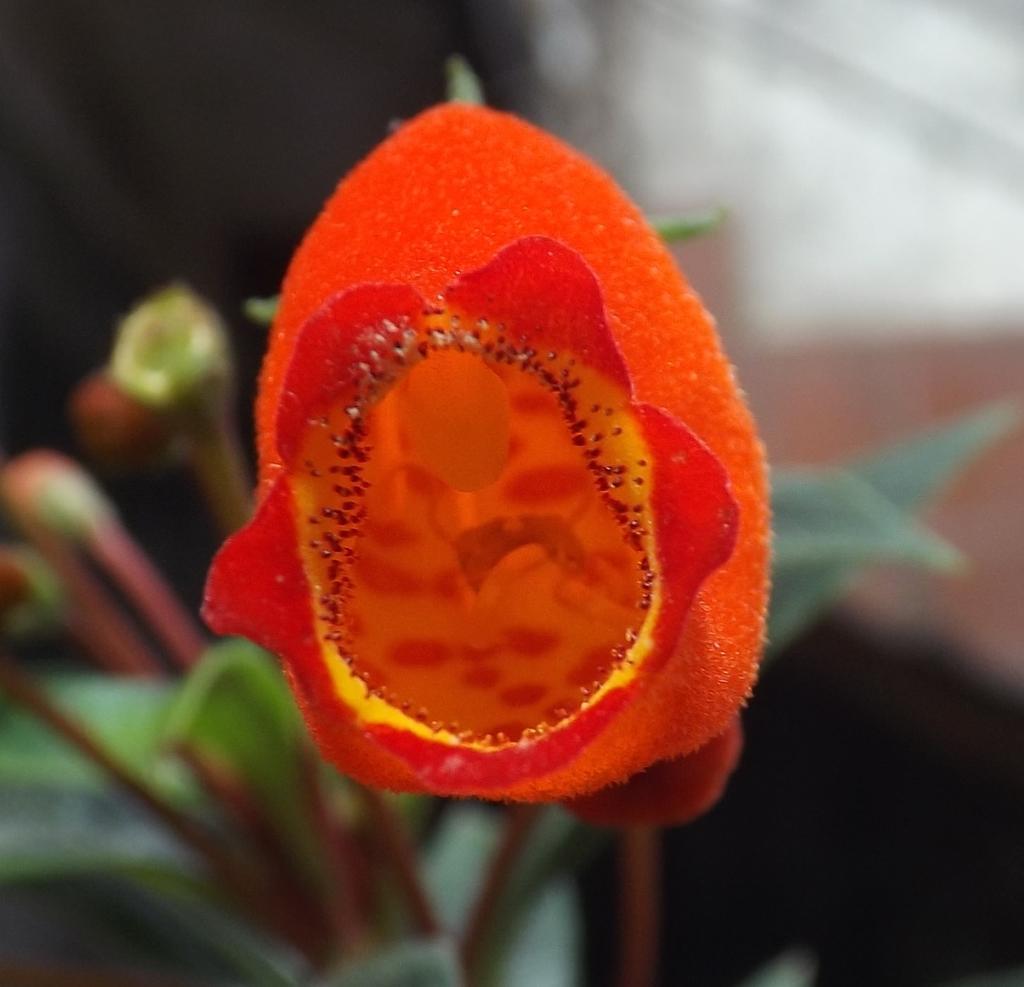Describe this image in one or two sentences. This image consist of a flower which is in the center. 